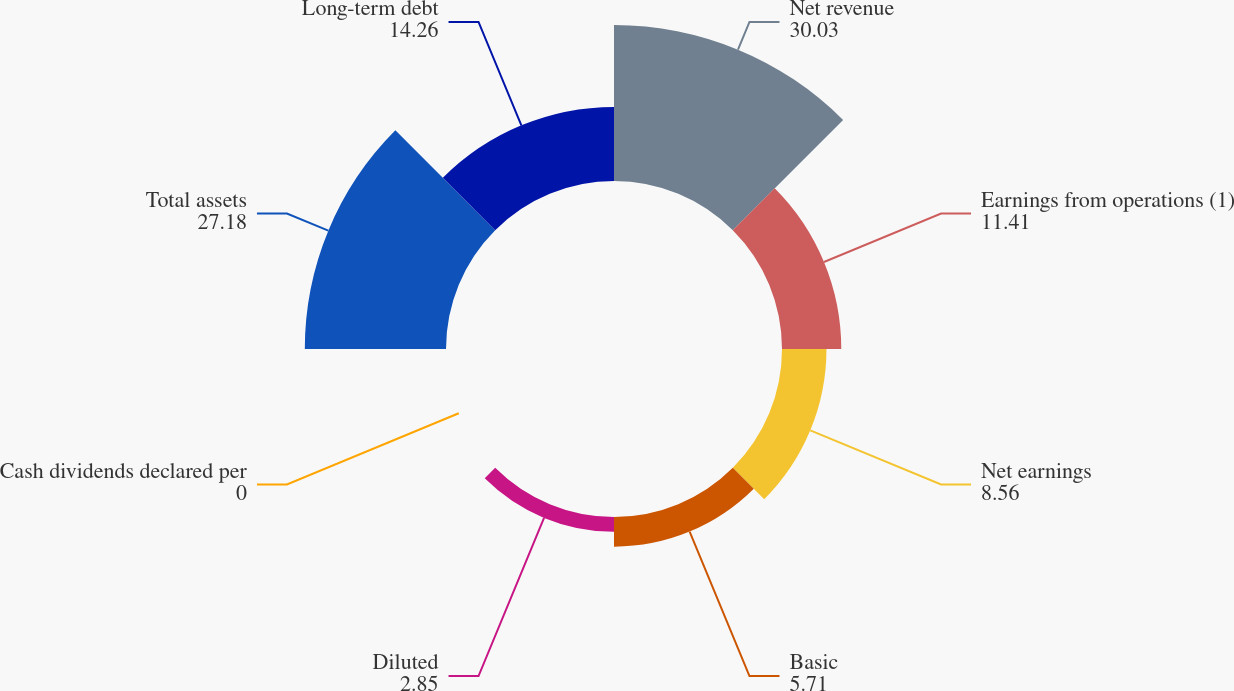Convert chart to OTSL. <chart><loc_0><loc_0><loc_500><loc_500><pie_chart><fcel>Net revenue<fcel>Earnings from operations (1)<fcel>Net earnings<fcel>Basic<fcel>Diluted<fcel>Cash dividends declared per<fcel>Total assets<fcel>Long-term debt<nl><fcel>30.03%<fcel>11.41%<fcel>8.56%<fcel>5.71%<fcel>2.85%<fcel>0.0%<fcel>27.18%<fcel>14.26%<nl></chart> 